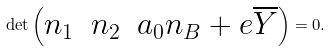<formula> <loc_0><loc_0><loc_500><loc_500>\det \begin{pmatrix} n _ { 1 } & n _ { 2 } & a _ { 0 } n _ { B } + e \overline { Y } \end{pmatrix} = 0 .</formula> 